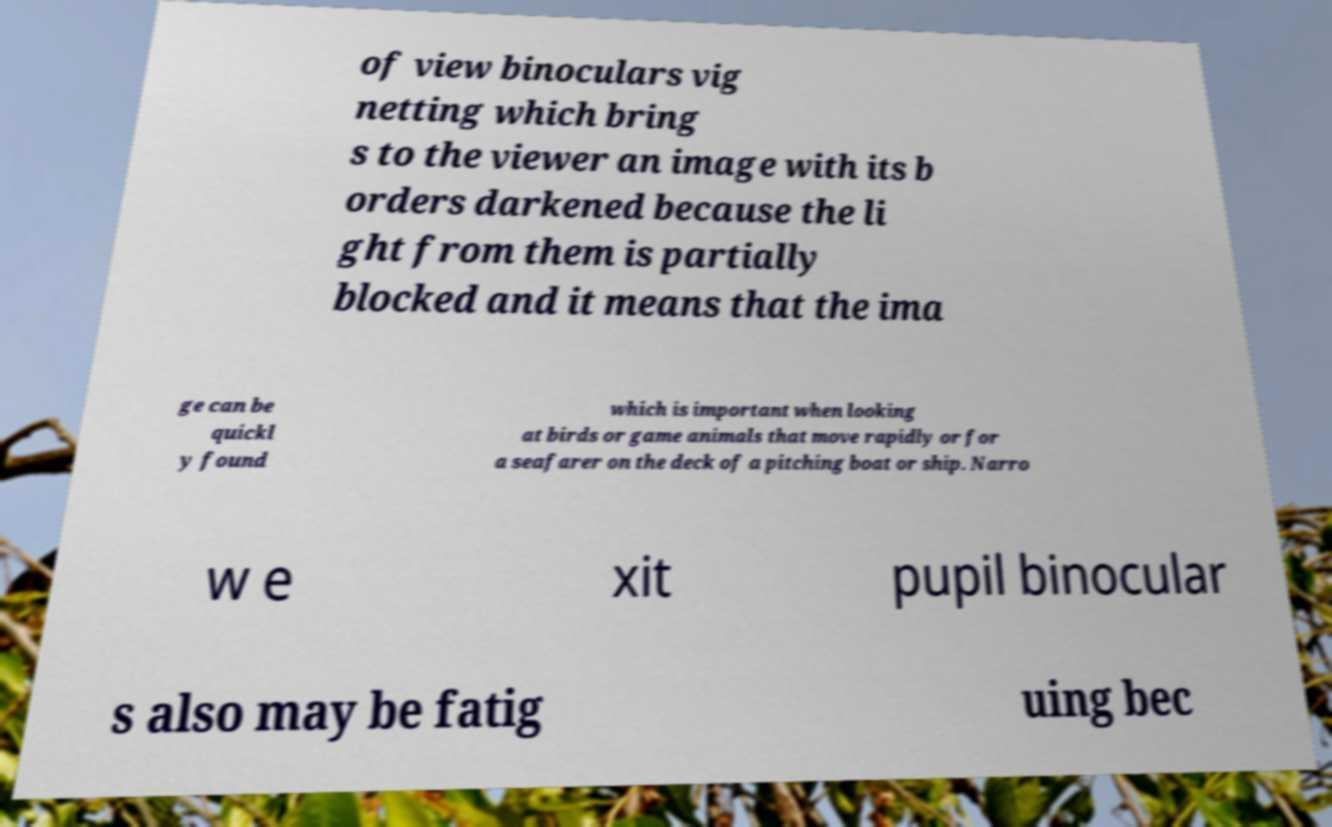Can you accurately transcribe the text from the provided image for me? of view binoculars vig netting which bring s to the viewer an image with its b orders darkened because the li ght from them is partially blocked and it means that the ima ge can be quickl y found which is important when looking at birds or game animals that move rapidly or for a seafarer on the deck of a pitching boat or ship. Narro w e xit pupil binocular s also may be fatig uing bec 